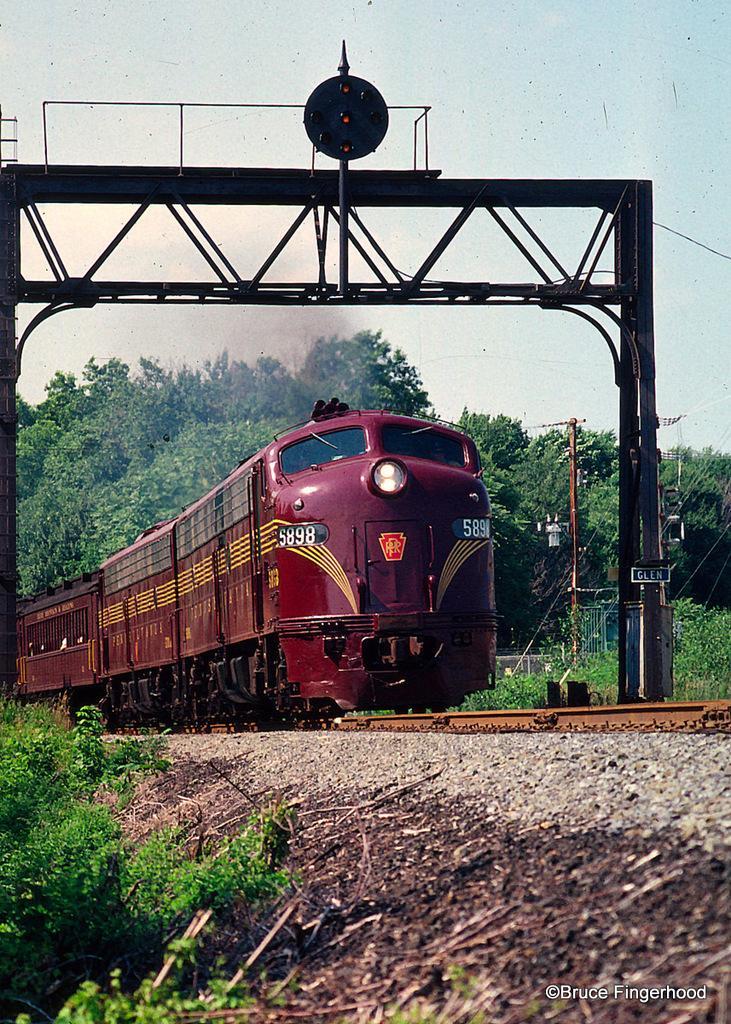Describe this image in one or two sentences. This image consists of a train in red color. At the bottom, there are tracks. To the left, there are small plants. In the background, there are many trees. 